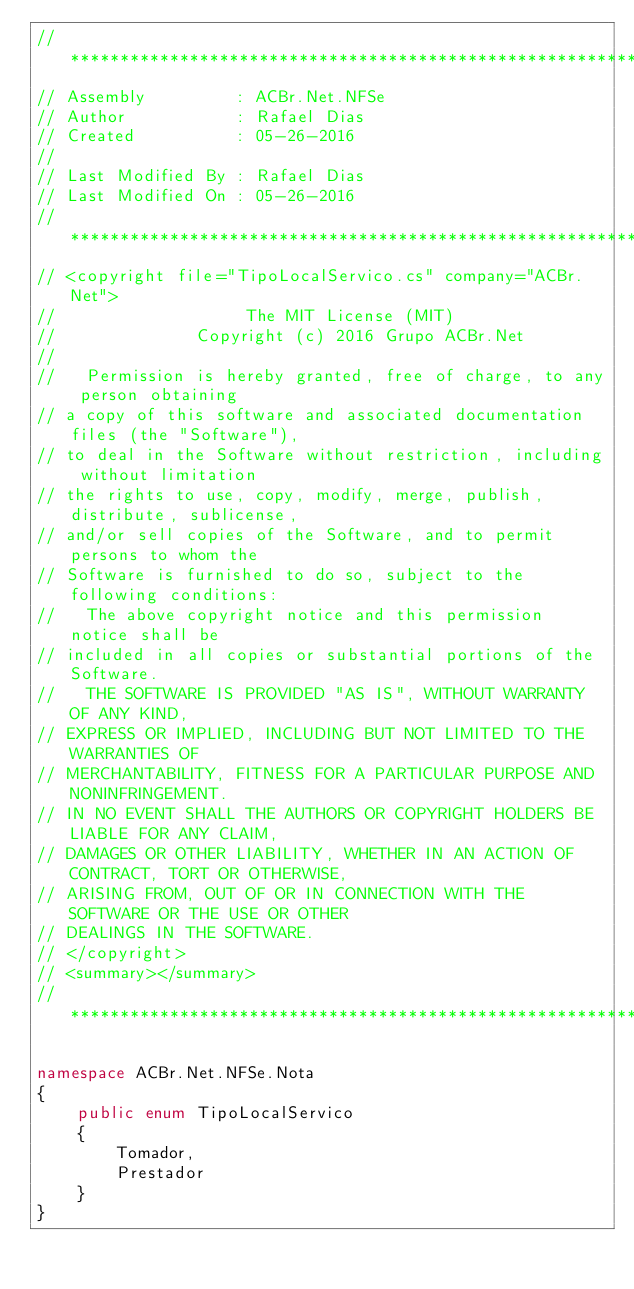Convert code to text. <code><loc_0><loc_0><loc_500><loc_500><_C#_>// ***********************************************************************
// Assembly         : ACBr.Net.NFSe
// Author           : Rafael Dias
// Created          : 05-26-2016
//
// Last Modified By : Rafael Dias
// Last Modified On : 05-26-2016
// ***********************************************************************
// <copyright file="TipoLocalServico.cs" company="ACBr.Net">
//		        		   The MIT License (MIT)
//	     		    Copyright (c) 2016 Grupo ACBr.Net
//
//	 Permission is hereby granted, free of charge, to any person obtaining
// a copy of this software and associated documentation files (the "Software"),
// to deal in the Software without restriction, including without limitation
// the rights to use, copy, modify, merge, publish, distribute, sublicense,
// and/or sell copies of the Software, and to permit persons to whom the
// Software is furnished to do so, subject to the following conditions:
//	 The above copyright notice and this permission notice shall be
// included in all copies or substantial portions of the Software.
//	 THE SOFTWARE IS PROVIDED "AS IS", WITHOUT WARRANTY OF ANY KIND,
// EXPRESS OR IMPLIED, INCLUDING BUT NOT LIMITED TO THE WARRANTIES OF
// MERCHANTABILITY, FITNESS FOR A PARTICULAR PURPOSE AND NONINFRINGEMENT.
// IN NO EVENT SHALL THE AUTHORS OR COPYRIGHT HOLDERS BE LIABLE FOR ANY CLAIM,
// DAMAGES OR OTHER LIABILITY, WHETHER IN AN ACTION OF CONTRACT, TORT OR OTHERWISE,
// ARISING FROM, OUT OF OR IN CONNECTION WITH THE SOFTWARE OR THE USE OR OTHER
// DEALINGS IN THE SOFTWARE.
// </copyright>
// <summary></summary>
// ***********************************************************************

namespace ACBr.Net.NFSe.Nota
{
    public enum TipoLocalServico
    {
        Tomador,
        Prestador
    }
}</code> 